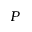Convert formula to latex. <formula><loc_0><loc_0><loc_500><loc_500>P</formula> 